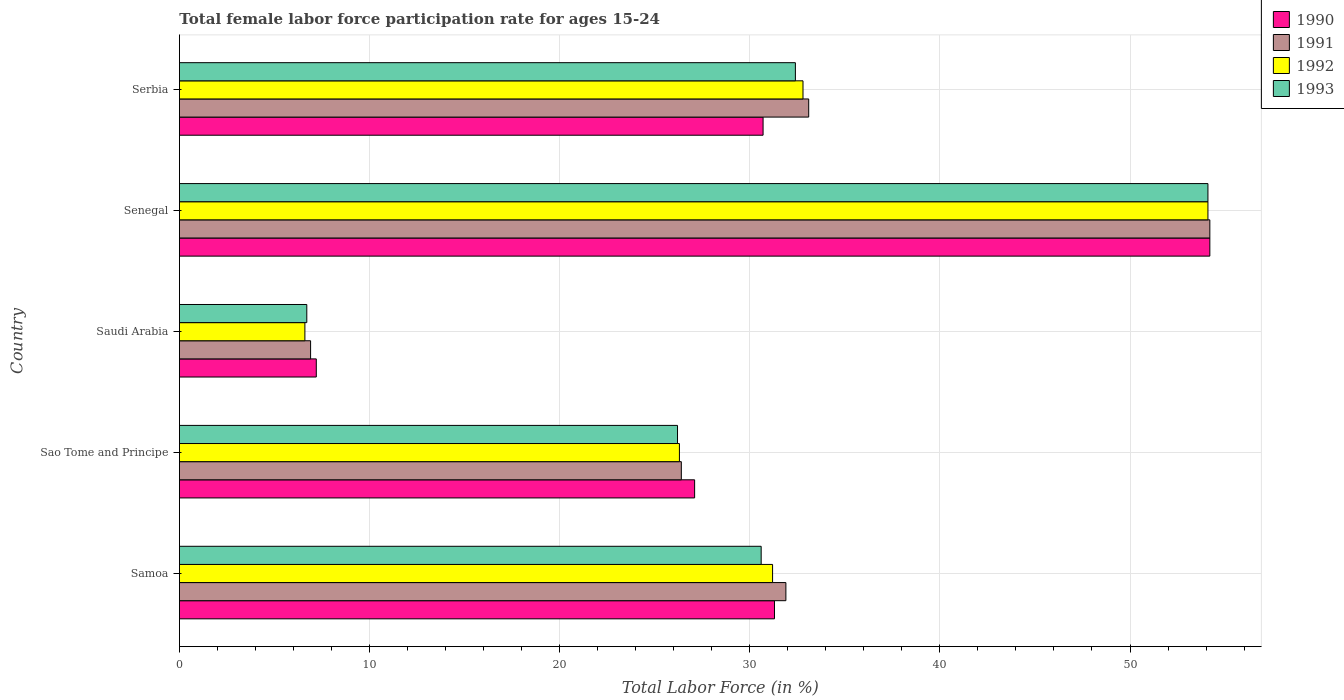How many groups of bars are there?
Make the answer very short. 5. Are the number of bars per tick equal to the number of legend labels?
Give a very brief answer. Yes. How many bars are there on the 4th tick from the top?
Your answer should be compact. 4. What is the label of the 2nd group of bars from the top?
Keep it short and to the point. Senegal. In how many cases, is the number of bars for a given country not equal to the number of legend labels?
Ensure brevity in your answer.  0. What is the female labor force participation rate in 1992 in Serbia?
Provide a short and direct response. 32.8. Across all countries, what is the maximum female labor force participation rate in 1991?
Your answer should be compact. 54.2. Across all countries, what is the minimum female labor force participation rate in 1993?
Ensure brevity in your answer.  6.7. In which country was the female labor force participation rate in 1991 maximum?
Keep it short and to the point. Senegal. In which country was the female labor force participation rate in 1991 minimum?
Your answer should be very brief. Saudi Arabia. What is the total female labor force participation rate in 1993 in the graph?
Make the answer very short. 150. What is the difference between the female labor force participation rate in 1991 in Samoa and that in Sao Tome and Principe?
Offer a terse response. 5.5. What is the difference between the female labor force participation rate in 1992 in Serbia and the female labor force participation rate in 1993 in Sao Tome and Principe?
Provide a short and direct response. 6.6. What is the average female labor force participation rate in 1991 per country?
Keep it short and to the point. 30.5. What is the difference between the female labor force participation rate in 1991 and female labor force participation rate in 1990 in Serbia?
Give a very brief answer. 2.4. What is the ratio of the female labor force participation rate in 1992 in Sao Tome and Principe to that in Serbia?
Give a very brief answer. 0.8. What is the difference between the highest and the second highest female labor force participation rate in 1993?
Your answer should be very brief. 21.7. What is the difference between the highest and the lowest female labor force participation rate in 1992?
Ensure brevity in your answer.  47.5. In how many countries, is the female labor force participation rate in 1993 greater than the average female labor force participation rate in 1993 taken over all countries?
Offer a very short reply. 3. Is it the case that in every country, the sum of the female labor force participation rate in 1992 and female labor force participation rate in 1990 is greater than the sum of female labor force participation rate in 1993 and female labor force participation rate in 1991?
Give a very brief answer. No. What does the 2nd bar from the top in Sao Tome and Principe represents?
Ensure brevity in your answer.  1992. Are all the bars in the graph horizontal?
Provide a short and direct response. Yes. How many countries are there in the graph?
Keep it short and to the point. 5. How many legend labels are there?
Offer a very short reply. 4. What is the title of the graph?
Your response must be concise. Total female labor force participation rate for ages 15-24. Does "2013" appear as one of the legend labels in the graph?
Your answer should be very brief. No. What is the Total Labor Force (in %) of 1990 in Samoa?
Your answer should be compact. 31.3. What is the Total Labor Force (in %) in 1991 in Samoa?
Keep it short and to the point. 31.9. What is the Total Labor Force (in %) of 1992 in Samoa?
Keep it short and to the point. 31.2. What is the Total Labor Force (in %) in 1993 in Samoa?
Offer a terse response. 30.6. What is the Total Labor Force (in %) in 1990 in Sao Tome and Principe?
Offer a terse response. 27.1. What is the Total Labor Force (in %) of 1991 in Sao Tome and Principe?
Offer a very short reply. 26.4. What is the Total Labor Force (in %) in 1992 in Sao Tome and Principe?
Provide a succinct answer. 26.3. What is the Total Labor Force (in %) of 1993 in Sao Tome and Principe?
Your answer should be compact. 26.2. What is the Total Labor Force (in %) of 1990 in Saudi Arabia?
Your response must be concise. 7.2. What is the Total Labor Force (in %) in 1991 in Saudi Arabia?
Give a very brief answer. 6.9. What is the Total Labor Force (in %) of 1992 in Saudi Arabia?
Keep it short and to the point. 6.6. What is the Total Labor Force (in %) of 1993 in Saudi Arabia?
Your answer should be very brief. 6.7. What is the Total Labor Force (in %) of 1990 in Senegal?
Offer a terse response. 54.2. What is the Total Labor Force (in %) of 1991 in Senegal?
Provide a short and direct response. 54.2. What is the Total Labor Force (in %) of 1992 in Senegal?
Offer a terse response. 54.1. What is the Total Labor Force (in %) of 1993 in Senegal?
Give a very brief answer. 54.1. What is the Total Labor Force (in %) in 1990 in Serbia?
Ensure brevity in your answer.  30.7. What is the Total Labor Force (in %) of 1991 in Serbia?
Ensure brevity in your answer.  33.1. What is the Total Labor Force (in %) of 1992 in Serbia?
Offer a very short reply. 32.8. What is the Total Labor Force (in %) in 1993 in Serbia?
Your answer should be compact. 32.4. Across all countries, what is the maximum Total Labor Force (in %) in 1990?
Offer a very short reply. 54.2. Across all countries, what is the maximum Total Labor Force (in %) of 1991?
Offer a terse response. 54.2. Across all countries, what is the maximum Total Labor Force (in %) of 1992?
Your response must be concise. 54.1. Across all countries, what is the maximum Total Labor Force (in %) in 1993?
Your response must be concise. 54.1. Across all countries, what is the minimum Total Labor Force (in %) in 1990?
Your answer should be very brief. 7.2. Across all countries, what is the minimum Total Labor Force (in %) in 1991?
Offer a terse response. 6.9. Across all countries, what is the minimum Total Labor Force (in %) of 1992?
Provide a succinct answer. 6.6. Across all countries, what is the minimum Total Labor Force (in %) of 1993?
Offer a very short reply. 6.7. What is the total Total Labor Force (in %) in 1990 in the graph?
Make the answer very short. 150.5. What is the total Total Labor Force (in %) of 1991 in the graph?
Provide a short and direct response. 152.5. What is the total Total Labor Force (in %) of 1992 in the graph?
Offer a terse response. 151. What is the total Total Labor Force (in %) of 1993 in the graph?
Provide a short and direct response. 150. What is the difference between the Total Labor Force (in %) in 1991 in Samoa and that in Sao Tome and Principe?
Ensure brevity in your answer.  5.5. What is the difference between the Total Labor Force (in %) in 1993 in Samoa and that in Sao Tome and Principe?
Your answer should be compact. 4.4. What is the difference between the Total Labor Force (in %) of 1990 in Samoa and that in Saudi Arabia?
Ensure brevity in your answer.  24.1. What is the difference between the Total Labor Force (in %) in 1992 in Samoa and that in Saudi Arabia?
Provide a short and direct response. 24.6. What is the difference between the Total Labor Force (in %) of 1993 in Samoa and that in Saudi Arabia?
Ensure brevity in your answer.  23.9. What is the difference between the Total Labor Force (in %) in 1990 in Samoa and that in Senegal?
Make the answer very short. -22.9. What is the difference between the Total Labor Force (in %) of 1991 in Samoa and that in Senegal?
Make the answer very short. -22.3. What is the difference between the Total Labor Force (in %) of 1992 in Samoa and that in Senegal?
Keep it short and to the point. -22.9. What is the difference between the Total Labor Force (in %) of 1993 in Samoa and that in Senegal?
Give a very brief answer. -23.5. What is the difference between the Total Labor Force (in %) in 1991 in Samoa and that in Serbia?
Make the answer very short. -1.2. What is the difference between the Total Labor Force (in %) in 1990 in Sao Tome and Principe and that in Saudi Arabia?
Ensure brevity in your answer.  19.9. What is the difference between the Total Labor Force (in %) of 1991 in Sao Tome and Principe and that in Saudi Arabia?
Keep it short and to the point. 19.5. What is the difference between the Total Labor Force (in %) of 1992 in Sao Tome and Principe and that in Saudi Arabia?
Give a very brief answer. 19.7. What is the difference between the Total Labor Force (in %) in 1993 in Sao Tome and Principe and that in Saudi Arabia?
Give a very brief answer. 19.5. What is the difference between the Total Labor Force (in %) in 1990 in Sao Tome and Principe and that in Senegal?
Give a very brief answer. -27.1. What is the difference between the Total Labor Force (in %) in 1991 in Sao Tome and Principe and that in Senegal?
Offer a very short reply. -27.8. What is the difference between the Total Labor Force (in %) of 1992 in Sao Tome and Principe and that in Senegal?
Ensure brevity in your answer.  -27.8. What is the difference between the Total Labor Force (in %) in 1993 in Sao Tome and Principe and that in Senegal?
Your response must be concise. -27.9. What is the difference between the Total Labor Force (in %) of 1991 in Sao Tome and Principe and that in Serbia?
Offer a terse response. -6.7. What is the difference between the Total Labor Force (in %) of 1992 in Sao Tome and Principe and that in Serbia?
Provide a short and direct response. -6.5. What is the difference between the Total Labor Force (in %) in 1993 in Sao Tome and Principe and that in Serbia?
Ensure brevity in your answer.  -6.2. What is the difference between the Total Labor Force (in %) in 1990 in Saudi Arabia and that in Senegal?
Keep it short and to the point. -47. What is the difference between the Total Labor Force (in %) in 1991 in Saudi Arabia and that in Senegal?
Offer a very short reply. -47.3. What is the difference between the Total Labor Force (in %) in 1992 in Saudi Arabia and that in Senegal?
Give a very brief answer. -47.5. What is the difference between the Total Labor Force (in %) of 1993 in Saudi Arabia and that in Senegal?
Make the answer very short. -47.4. What is the difference between the Total Labor Force (in %) in 1990 in Saudi Arabia and that in Serbia?
Offer a terse response. -23.5. What is the difference between the Total Labor Force (in %) in 1991 in Saudi Arabia and that in Serbia?
Your answer should be compact. -26.2. What is the difference between the Total Labor Force (in %) in 1992 in Saudi Arabia and that in Serbia?
Ensure brevity in your answer.  -26.2. What is the difference between the Total Labor Force (in %) of 1993 in Saudi Arabia and that in Serbia?
Keep it short and to the point. -25.7. What is the difference between the Total Labor Force (in %) in 1990 in Senegal and that in Serbia?
Keep it short and to the point. 23.5. What is the difference between the Total Labor Force (in %) in 1991 in Senegal and that in Serbia?
Provide a succinct answer. 21.1. What is the difference between the Total Labor Force (in %) of 1992 in Senegal and that in Serbia?
Keep it short and to the point. 21.3. What is the difference between the Total Labor Force (in %) in 1993 in Senegal and that in Serbia?
Offer a very short reply. 21.7. What is the difference between the Total Labor Force (in %) in 1990 in Samoa and the Total Labor Force (in %) in 1993 in Sao Tome and Principe?
Make the answer very short. 5.1. What is the difference between the Total Labor Force (in %) of 1991 in Samoa and the Total Labor Force (in %) of 1992 in Sao Tome and Principe?
Your response must be concise. 5.6. What is the difference between the Total Labor Force (in %) in 1991 in Samoa and the Total Labor Force (in %) in 1993 in Sao Tome and Principe?
Ensure brevity in your answer.  5.7. What is the difference between the Total Labor Force (in %) in 1990 in Samoa and the Total Labor Force (in %) in 1991 in Saudi Arabia?
Keep it short and to the point. 24.4. What is the difference between the Total Labor Force (in %) of 1990 in Samoa and the Total Labor Force (in %) of 1992 in Saudi Arabia?
Keep it short and to the point. 24.7. What is the difference between the Total Labor Force (in %) in 1990 in Samoa and the Total Labor Force (in %) in 1993 in Saudi Arabia?
Provide a short and direct response. 24.6. What is the difference between the Total Labor Force (in %) in 1991 in Samoa and the Total Labor Force (in %) in 1992 in Saudi Arabia?
Provide a succinct answer. 25.3. What is the difference between the Total Labor Force (in %) in 1991 in Samoa and the Total Labor Force (in %) in 1993 in Saudi Arabia?
Your answer should be very brief. 25.2. What is the difference between the Total Labor Force (in %) of 1992 in Samoa and the Total Labor Force (in %) of 1993 in Saudi Arabia?
Your answer should be very brief. 24.5. What is the difference between the Total Labor Force (in %) in 1990 in Samoa and the Total Labor Force (in %) in 1991 in Senegal?
Make the answer very short. -22.9. What is the difference between the Total Labor Force (in %) of 1990 in Samoa and the Total Labor Force (in %) of 1992 in Senegal?
Give a very brief answer. -22.8. What is the difference between the Total Labor Force (in %) of 1990 in Samoa and the Total Labor Force (in %) of 1993 in Senegal?
Offer a terse response. -22.8. What is the difference between the Total Labor Force (in %) in 1991 in Samoa and the Total Labor Force (in %) in 1992 in Senegal?
Your answer should be very brief. -22.2. What is the difference between the Total Labor Force (in %) of 1991 in Samoa and the Total Labor Force (in %) of 1993 in Senegal?
Keep it short and to the point. -22.2. What is the difference between the Total Labor Force (in %) in 1992 in Samoa and the Total Labor Force (in %) in 1993 in Senegal?
Offer a very short reply. -22.9. What is the difference between the Total Labor Force (in %) in 1990 in Samoa and the Total Labor Force (in %) in 1991 in Serbia?
Keep it short and to the point. -1.8. What is the difference between the Total Labor Force (in %) of 1990 in Samoa and the Total Labor Force (in %) of 1992 in Serbia?
Provide a short and direct response. -1.5. What is the difference between the Total Labor Force (in %) of 1990 in Sao Tome and Principe and the Total Labor Force (in %) of 1991 in Saudi Arabia?
Offer a terse response. 20.2. What is the difference between the Total Labor Force (in %) of 1990 in Sao Tome and Principe and the Total Labor Force (in %) of 1993 in Saudi Arabia?
Ensure brevity in your answer.  20.4. What is the difference between the Total Labor Force (in %) in 1991 in Sao Tome and Principe and the Total Labor Force (in %) in 1992 in Saudi Arabia?
Ensure brevity in your answer.  19.8. What is the difference between the Total Labor Force (in %) in 1992 in Sao Tome and Principe and the Total Labor Force (in %) in 1993 in Saudi Arabia?
Give a very brief answer. 19.6. What is the difference between the Total Labor Force (in %) in 1990 in Sao Tome and Principe and the Total Labor Force (in %) in 1991 in Senegal?
Your answer should be very brief. -27.1. What is the difference between the Total Labor Force (in %) in 1990 in Sao Tome and Principe and the Total Labor Force (in %) in 1993 in Senegal?
Provide a succinct answer. -27. What is the difference between the Total Labor Force (in %) of 1991 in Sao Tome and Principe and the Total Labor Force (in %) of 1992 in Senegal?
Give a very brief answer. -27.7. What is the difference between the Total Labor Force (in %) in 1991 in Sao Tome and Principe and the Total Labor Force (in %) in 1993 in Senegal?
Offer a very short reply. -27.7. What is the difference between the Total Labor Force (in %) in 1992 in Sao Tome and Principe and the Total Labor Force (in %) in 1993 in Senegal?
Make the answer very short. -27.8. What is the difference between the Total Labor Force (in %) of 1990 in Sao Tome and Principe and the Total Labor Force (in %) of 1991 in Serbia?
Your response must be concise. -6. What is the difference between the Total Labor Force (in %) in 1991 in Sao Tome and Principe and the Total Labor Force (in %) in 1992 in Serbia?
Offer a very short reply. -6.4. What is the difference between the Total Labor Force (in %) in 1991 in Sao Tome and Principe and the Total Labor Force (in %) in 1993 in Serbia?
Your answer should be very brief. -6. What is the difference between the Total Labor Force (in %) in 1990 in Saudi Arabia and the Total Labor Force (in %) in 1991 in Senegal?
Offer a very short reply. -47. What is the difference between the Total Labor Force (in %) of 1990 in Saudi Arabia and the Total Labor Force (in %) of 1992 in Senegal?
Your response must be concise. -46.9. What is the difference between the Total Labor Force (in %) in 1990 in Saudi Arabia and the Total Labor Force (in %) in 1993 in Senegal?
Your response must be concise. -46.9. What is the difference between the Total Labor Force (in %) of 1991 in Saudi Arabia and the Total Labor Force (in %) of 1992 in Senegal?
Provide a short and direct response. -47.2. What is the difference between the Total Labor Force (in %) in 1991 in Saudi Arabia and the Total Labor Force (in %) in 1993 in Senegal?
Your answer should be compact. -47.2. What is the difference between the Total Labor Force (in %) in 1992 in Saudi Arabia and the Total Labor Force (in %) in 1993 in Senegal?
Offer a terse response. -47.5. What is the difference between the Total Labor Force (in %) of 1990 in Saudi Arabia and the Total Labor Force (in %) of 1991 in Serbia?
Keep it short and to the point. -25.9. What is the difference between the Total Labor Force (in %) of 1990 in Saudi Arabia and the Total Labor Force (in %) of 1992 in Serbia?
Your answer should be very brief. -25.6. What is the difference between the Total Labor Force (in %) of 1990 in Saudi Arabia and the Total Labor Force (in %) of 1993 in Serbia?
Keep it short and to the point. -25.2. What is the difference between the Total Labor Force (in %) of 1991 in Saudi Arabia and the Total Labor Force (in %) of 1992 in Serbia?
Give a very brief answer. -25.9. What is the difference between the Total Labor Force (in %) in 1991 in Saudi Arabia and the Total Labor Force (in %) in 1993 in Serbia?
Keep it short and to the point. -25.5. What is the difference between the Total Labor Force (in %) of 1992 in Saudi Arabia and the Total Labor Force (in %) of 1993 in Serbia?
Offer a very short reply. -25.8. What is the difference between the Total Labor Force (in %) in 1990 in Senegal and the Total Labor Force (in %) in 1991 in Serbia?
Offer a very short reply. 21.1. What is the difference between the Total Labor Force (in %) in 1990 in Senegal and the Total Labor Force (in %) in 1992 in Serbia?
Your answer should be compact. 21.4. What is the difference between the Total Labor Force (in %) of 1990 in Senegal and the Total Labor Force (in %) of 1993 in Serbia?
Your response must be concise. 21.8. What is the difference between the Total Labor Force (in %) in 1991 in Senegal and the Total Labor Force (in %) in 1992 in Serbia?
Offer a very short reply. 21.4. What is the difference between the Total Labor Force (in %) of 1991 in Senegal and the Total Labor Force (in %) of 1993 in Serbia?
Give a very brief answer. 21.8. What is the difference between the Total Labor Force (in %) of 1992 in Senegal and the Total Labor Force (in %) of 1993 in Serbia?
Make the answer very short. 21.7. What is the average Total Labor Force (in %) of 1990 per country?
Keep it short and to the point. 30.1. What is the average Total Labor Force (in %) of 1991 per country?
Keep it short and to the point. 30.5. What is the average Total Labor Force (in %) of 1992 per country?
Offer a very short reply. 30.2. What is the difference between the Total Labor Force (in %) in 1990 and Total Labor Force (in %) in 1991 in Samoa?
Your response must be concise. -0.6. What is the difference between the Total Labor Force (in %) of 1990 and Total Labor Force (in %) of 1992 in Samoa?
Make the answer very short. 0.1. What is the difference between the Total Labor Force (in %) in 1991 and Total Labor Force (in %) in 1993 in Samoa?
Give a very brief answer. 1.3. What is the difference between the Total Labor Force (in %) in 1992 and Total Labor Force (in %) in 1993 in Samoa?
Keep it short and to the point. 0.6. What is the difference between the Total Labor Force (in %) of 1990 and Total Labor Force (in %) of 1991 in Sao Tome and Principe?
Your answer should be compact. 0.7. What is the difference between the Total Labor Force (in %) in 1990 and Total Labor Force (in %) in 1992 in Sao Tome and Principe?
Provide a short and direct response. 0.8. What is the difference between the Total Labor Force (in %) of 1990 and Total Labor Force (in %) of 1993 in Sao Tome and Principe?
Ensure brevity in your answer.  0.9. What is the difference between the Total Labor Force (in %) in 1992 and Total Labor Force (in %) in 1993 in Sao Tome and Principe?
Offer a very short reply. 0.1. What is the difference between the Total Labor Force (in %) of 1990 and Total Labor Force (in %) of 1993 in Saudi Arabia?
Offer a very short reply. 0.5. What is the difference between the Total Labor Force (in %) in 1991 and Total Labor Force (in %) in 1992 in Saudi Arabia?
Your answer should be compact. 0.3. What is the difference between the Total Labor Force (in %) of 1990 and Total Labor Force (in %) of 1992 in Senegal?
Ensure brevity in your answer.  0.1. What is the difference between the Total Labor Force (in %) of 1991 and Total Labor Force (in %) of 1993 in Senegal?
Your answer should be compact. 0.1. What is the difference between the Total Labor Force (in %) in 1992 and Total Labor Force (in %) in 1993 in Senegal?
Your answer should be compact. 0. What is the difference between the Total Labor Force (in %) in 1990 and Total Labor Force (in %) in 1991 in Serbia?
Offer a terse response. -2.4. What is the difference between the Total Labor Force (in %) of 1990 and Total Labor Force (in %) of 1993 in Serbia?
Keep it short and to the point. -1.7. What is the difference between the Total Labor Force (in %) of 1991 and Total Labor Force (in %) of 1992 in Serbia?
Provide a short and direct response. 0.3. What is the difference between the Total Labor Force (in %) in 1991 and Total Labor Force (in %) in 1993 in Serbia?
Make the answer very short. 0.7. What is the difference between the Total Labor Force (in %) of 1992 and Total Labor Force (in %) of 1993 in Serbia?
Provide a succinct answer. 0.4. What is the ratio of the Total Labor Force (in %) of 1990 in Samoa to that in Sao Tome and Principe?
Ensure brevity in your answer.  1.16. What is the ratio of the Total Labor Force (in %) of 1991 in Samoa to that in Sao Tome and Principe?
Ensure brevity in your answer.  1.21. What is the ratio of the Total Labor Force (in %) of 1992 in Samoa to that in Sao Tome and Principe?
Keep it short and to the point. 1.19. What is the ratio of the Total Labor Force (in %) of 1993 in Samoa to that in Sao Tome and Principe?
Your answer should be very brief. 1.17. What is the ratio of the Total Labor Force (in %) in 1990 in Samoa to that in Saudi Arabia?
Provide a succinct answer. 4.35. What is the ratio of the Total Labor Force (in %) in 1991 in Samoa to that in Saudi Arabia?
Ensure brevity in your answer.  4.62. What is the ratio of the Total Labor Force (in %) of 1992 in Samoa to that in Saudi Arabia?
Your response must be concise. 4.73. What is the ratio of the Total Labor Force (in %) in 1993 in Samoa to that in Saudi Arabia?
Your answer should be compact. 4.57. What is the ratio of the Total Labor Force (in %) in 1990 in Samoa to that in Senegal?
Offer a very short reply. 0.58. What is the ratio of the Total Labor Force (in %) in 1991 in Samoa to that in Senegal?
Offer a terse response. 0.59. What is the ratio of the Total Labor Force (in %) of 1992 in Samoa to that in Senegal?
Ensure brevity in your answer.  0.58. What is the ratio of the Total Labor Force (in %) of 1993 in Samoa to that in Senegal?
Ensure brevity in your answer.  0.57. What is the ratio of the Total Labor Force (in %) of 1990 in Samoa to that in Serbia?
Make the answer very short. 1.02. What is the ratio of the Total Labor Force (in %) of 1991 in Samoa to that in Serbia?
Ensure brevity in your answer.  0.96. What is the ratio of the Total Labor Force (in %) in 1992 in Samoa to that in Serbia?
Your answer should be very brief. 0.95. What is the ratio of the Total Labor Force (in %) in 1990 in Sao Tome and Principe to that in Saudi Arabia?
Give a very brief answer. 3.76. What is the ratio of the Total Labor Force (in %) of 1991 in Sao Tome and Principe to that in Saudi Arabia?
Keep it short and to the point. 3.83. What is the ratio of the Total Labor Force (in %) of 1992 in Sao Tome and Principe to that in Saudi Arabia?
Keep it short and to the point. 3.98. What is the ratio of the Total Labor Force (in %) in 1993 in Sao Tome and Principe to that in Saudi Arabia?
Your answer should be very brief. 3.91. What is the ratio of the Total Labor Force (in %) of 1991 in Sao Tome and Principe to that in Senegal?
Ensure brevity in your answer.  0.49. What is the ratio of the Total Labor Force (in %) of 1992 in Sao Tome and Principe to that in Senegal?
Offer a very short reply. 0.49. What is the ratio of the Total Labor Force (in %) in 1993 in Sao Tome and Principe to that in Senegal?
Your answer should be compact. 0.48. What is the ratio of the Total Labor Force (in %) of 1990 in Sao Tome and Principe to that in Serbia?
Ensure brevity in your answer.  0.88. What is the ratio of the Total Labor Force (in %) in 1991 in Sao Tome and Principe to that in Serbia?
Make the answer very short. 0.8. What is the ratio of the Total Labor Force (in %) of 1992 in Sao Tome and Principe to that in Serbia?
Your answer should be compact. 0.8. What is the ratio of the Total Labor Force (in %) in 1993 in Sao Tome and Principe to that in Serbia?
Provide a succinct answer. 0.81. What is the ratio of the Total Labor Force (in %) in 1990 in Saudi Arabia to that in Senegal?
Give a very brief answer. 0.13. What is the ratio of the Total Labor Force (in %) of 1991 in Saudi Arabia to that in Senegal?
Your response must be concise. 0.13. What is the ratio of the Total Labor Force (in %) in 1992 in Saudi Arabia to that in Senegal?
Ensure brevity in your answer.  0.12. What is the ratio of the Total Labor Force (in %) in 1993 in Saudi Arabia to that in Senegal?
Keep it short and to the point. 0.12. What is the ratio of the Total Labor Force (in %) of 1990 in Saudi Arabia to that in Serbia?
Make the answer very short. 0.23. What is the ratio of the Total Labor Force (in %) in 1991 in Saudi Arabia to that in Serbia?
Your answer should be very brief. 0.21. What is the ratio of the Total Labor Force (in %) of 1992 in Saudi Arabia to that in Serbia?
Keep it short and to the point. 0.2. What is the ratio of the Total Labor Force (in %) of 1993 in Saudi Arabia to that in Serbia?
Your answer should be compact. 0.21. What is the ratio of the Total Labor Force (in %) in 1990 in Senegal to that in Serbia?
Offer a very short reply. 1.77. What is the ratio of the Total Labor Force (in %) of 1991 in Senegal to that in Serbia?
Provide a succinct answer. 1.64. What is the ratio of the Total Labor Force (in %) of 1992 in Senegal to that in Serbia?
Your answer should be compact. 1.65. What is the ratio of the Total Labor Force (in %) of 1993 in Senegal to that in Serbia?
Ensure brevity in your answer.  1.67. What is the difference between the highest and the second highest Total Labor Force (in %) of 1990?
Your answer should be compact. 22.9. What is the difference between the highest and the second highest Total Labor Force (in %) in 1991?
Your answer should be compact. 21.1. What is the difference between the highest and the second highest Total Labor Force (in %) of 1992?
Your answer should be very brief. 21.3. What is the difference between the highest and the second highest Total Labor Force (in %) of 1993?
Ensure brevity in your answer.  21.7. What is the difference between the highest and the lowest Total Labor Force (in %) in 1991?
Provide a succinct answer. 47.3. What is the difference between the highest and the lowest Total Labor Force (in %) in 1992?
Your answer should be compact. 47.5. What is the difference between the highest and the lowest Total Labor Force (in %) of 1993?
Make the answer very short. 47.4. 